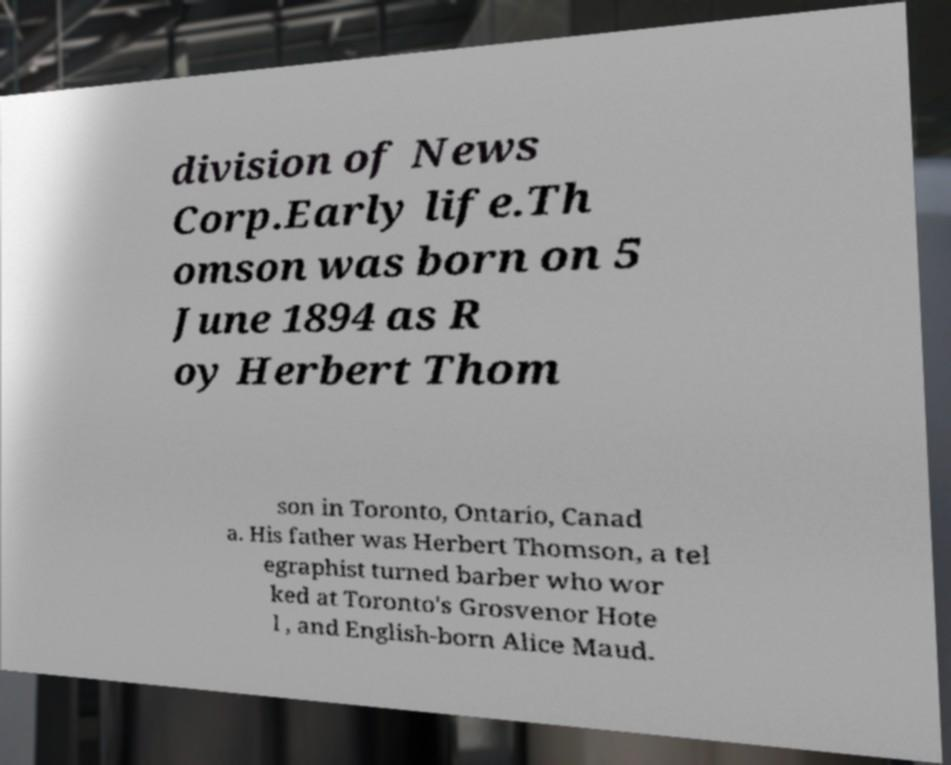Could you assist in decoding the text presented in this image and type it out clearly? division of News Corp.Early life.Th omson was born on 5 June 1894 as R oy Herbert Thom son in Toronto, Ontario, Canad a. His father was Herbert Thomson, a tel egraphist turned barber who wor ked at Toronto's Grosvenor Hote l , and English-born Alice Maud. 